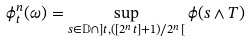Convert formula to latex. <formula><loc_0><loc_0><loc_500><loc_500>\phi ^ { n } _ { t } ( \omega ) = \sup _ { s \in \mathbb { D } \cap ] t , ( [ 2 ^ { n } t ] + 1 ) / 2 ^ { n } [ } \phi ( s \wedge T )</formula> 